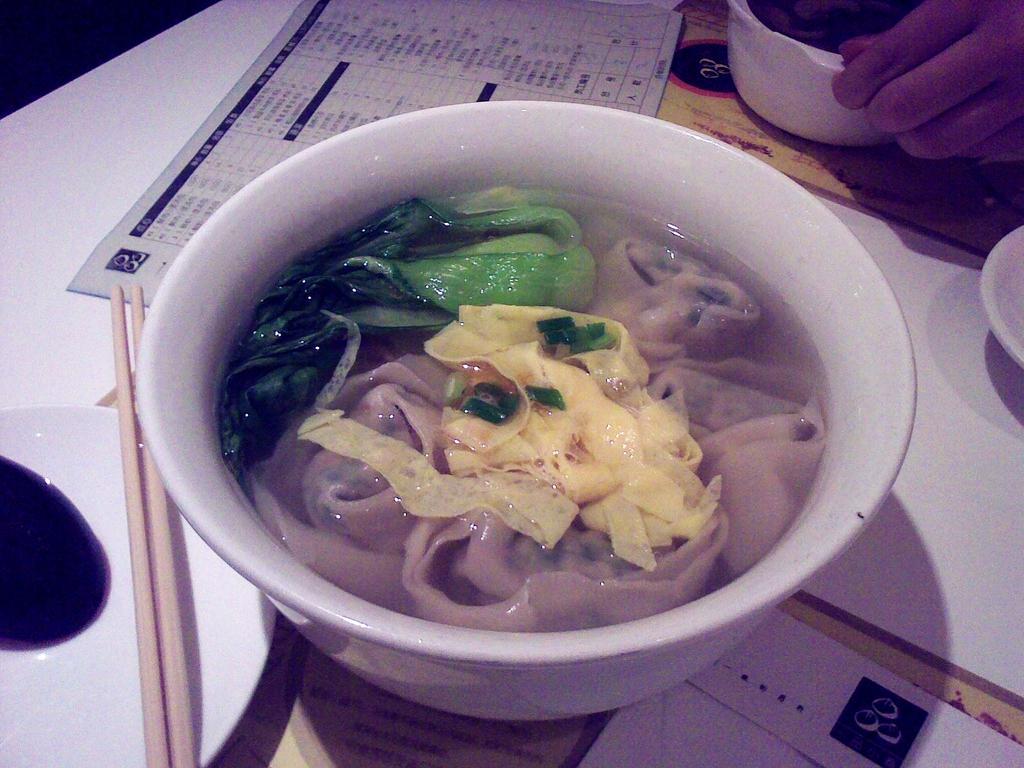Could you give a brief overview of what you see in this image? Here I can see a table on which a bowl, chopsticks, saucers and papers are placed. This bowl consists of water and some food item. At the top of this image I can see a person's hand holding a bowl. 